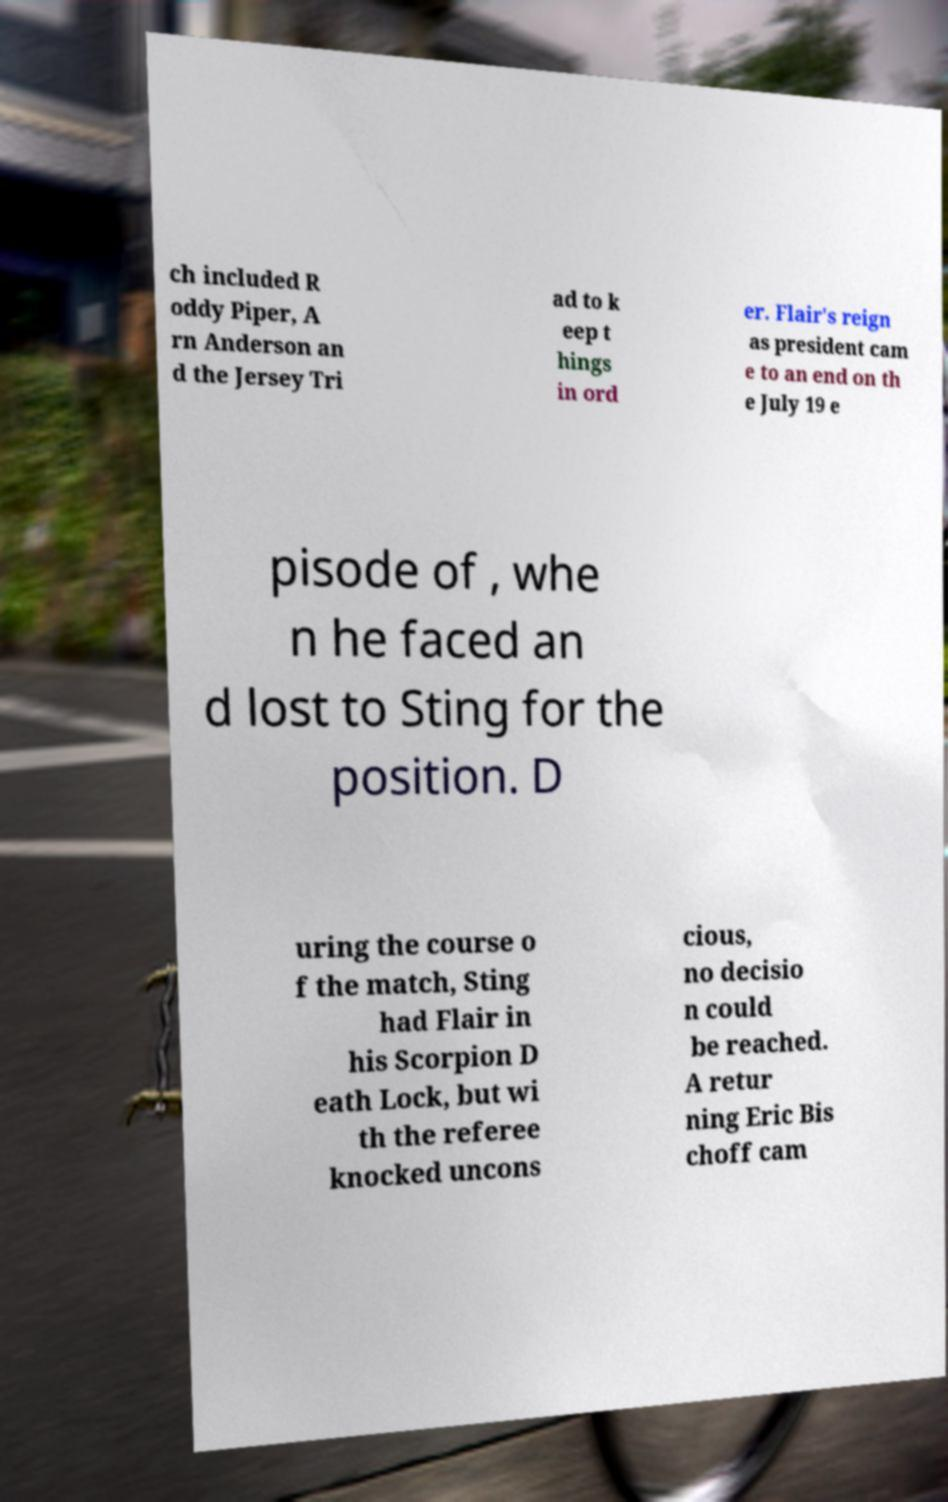Can you accurately transcribe the text from the provided image for me? ch included R oddy Piper, A rn Anderson an d the Jersey Tri ad to k eep t hings in ord er. Flair's reign as president cam e to an end on th e July 19 e pisode of , whe n he faced an d lost to Sting for the position. D uring the course o f the match, Sting had Flair in his Scorpion D eath Lock, but wi th the referee knocked uncons cious, no decisio n could be reached. A retur ning Eric Bis choff cam 